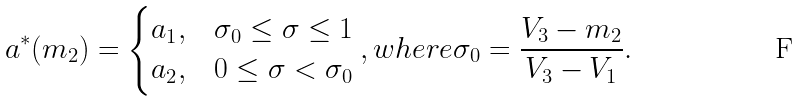Convert formula to latex. <formula><loc_0><loc_0><loc_500><loc_500>a ^ { * } ( m _ { 2 } ) = \begin{cases} a _ { 1 } , & \sigma _ { 0 } \leq \sigma \leq 1 \\ a _ { 2 } , & 0 \leq \sigma < \sigma _ { 0 } \end{cases} , w h e r e \sigma _ { 0 } = \frac { V _ { 3 } - m _ { 2 } } { V _ { 3 } - V _ { 1 } } .</formula> 